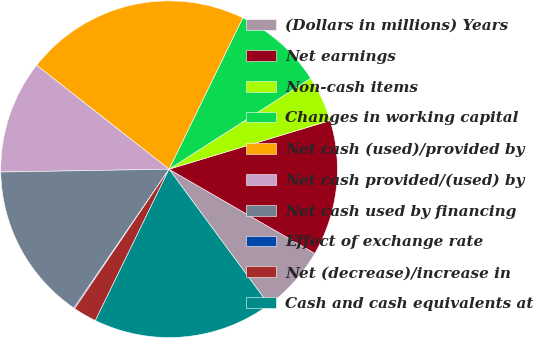Convert chart to OTSL. <chart><loc_0><loc_0><loc_500><loc_500><pie_chart><fcel>(Dollars in millions) Years<fcel>Net earnings<fcel>Non-cash items<fcel>Changes in working capital<fcel>Net cash (used)/provided by<fcel>Net cash provided/(used) by<fcel>Net cash used by financing<fcel>Effect of exchange rate<fcel>Net (decrease)/increase in<fcel>Cash and cash equivalents at<nl><fcel>6.56%<fcel>13.01%<fcel>4.41%<fcel>8.71%<fcel>21.62%<fcel>10.86%<fcel>15.16%<fcel>0.1%<fcel>2.26%<fcel>17.31%<nl></chart> 